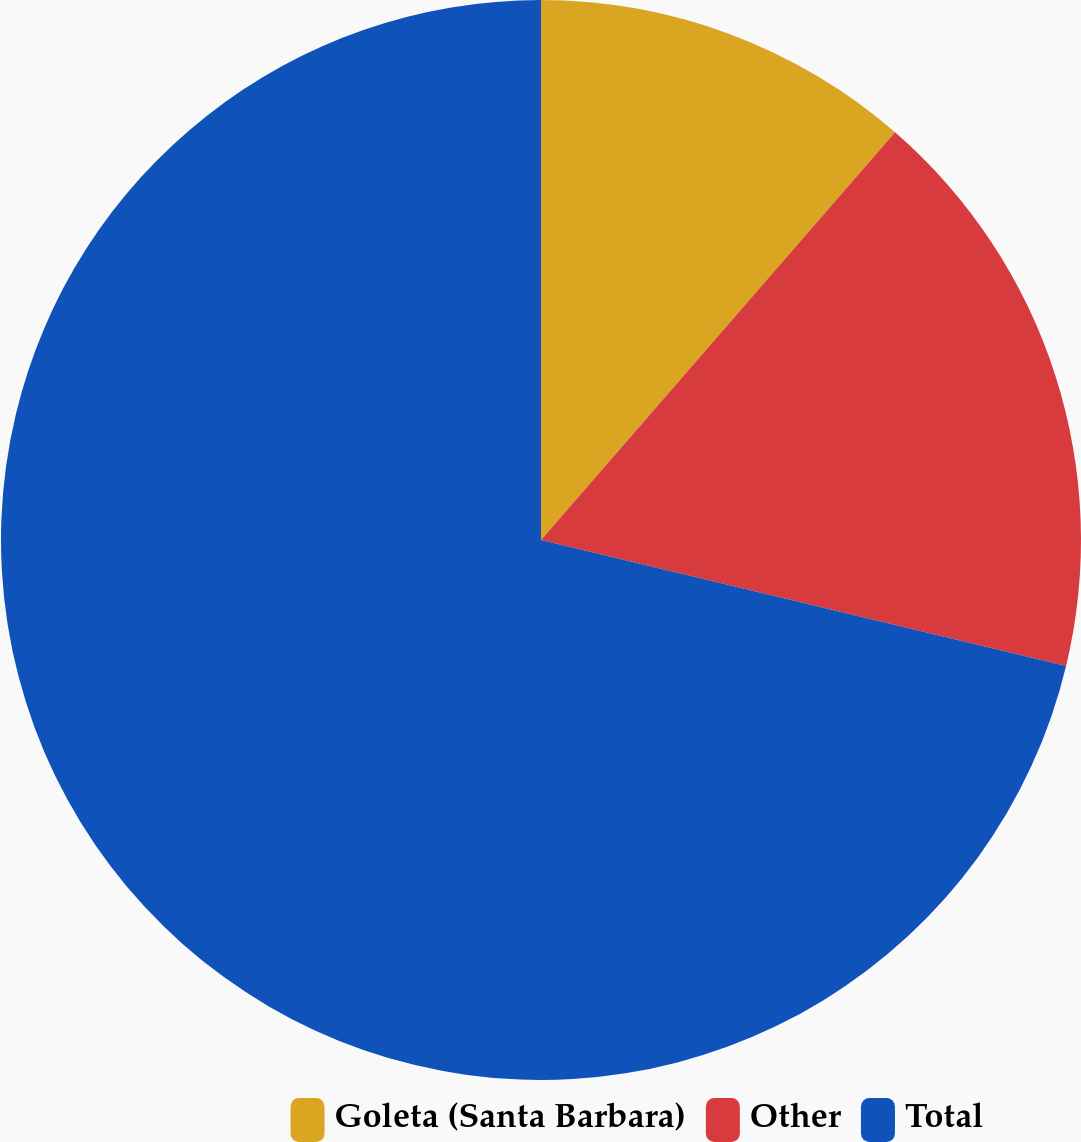<chart> <loc_0><loc_0><loc_500><loc_500><pie_chart><fcel>Goleta (Santa Barbara)<fcel>Other<fcel>Total<nl><fcel>11.38%<fcel>17.37%<fcel>71.25%<nl></chart> 